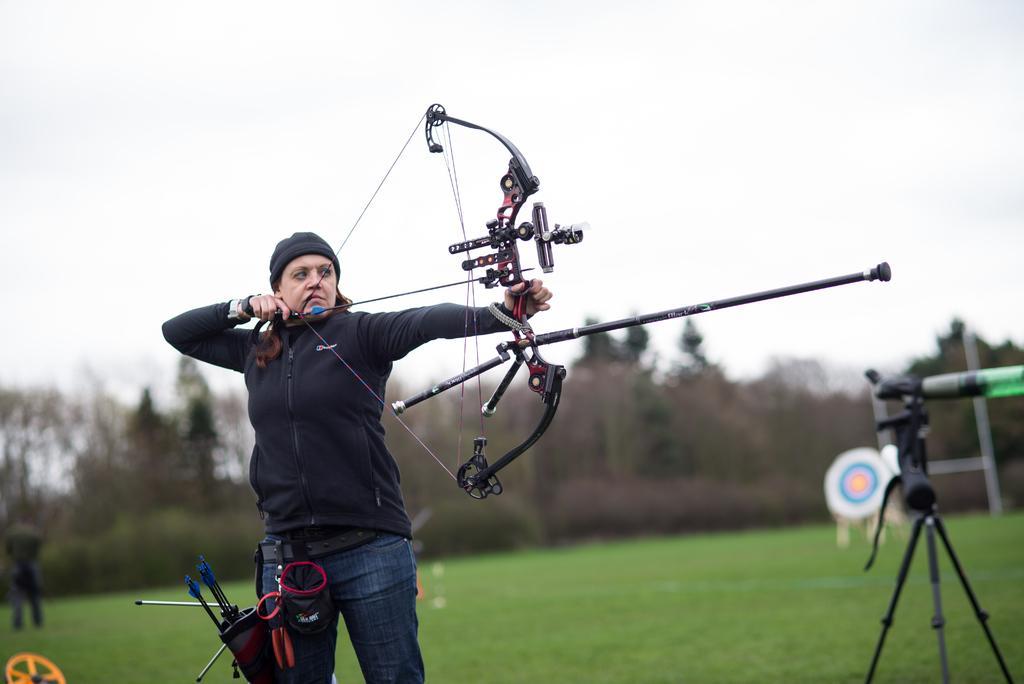Could you give a brief overview of what you see in this image? In this picture we can see a woman holding a bow with her hand and standing and in the background we can see a person, tripod stand, archery target, trees, sky. 